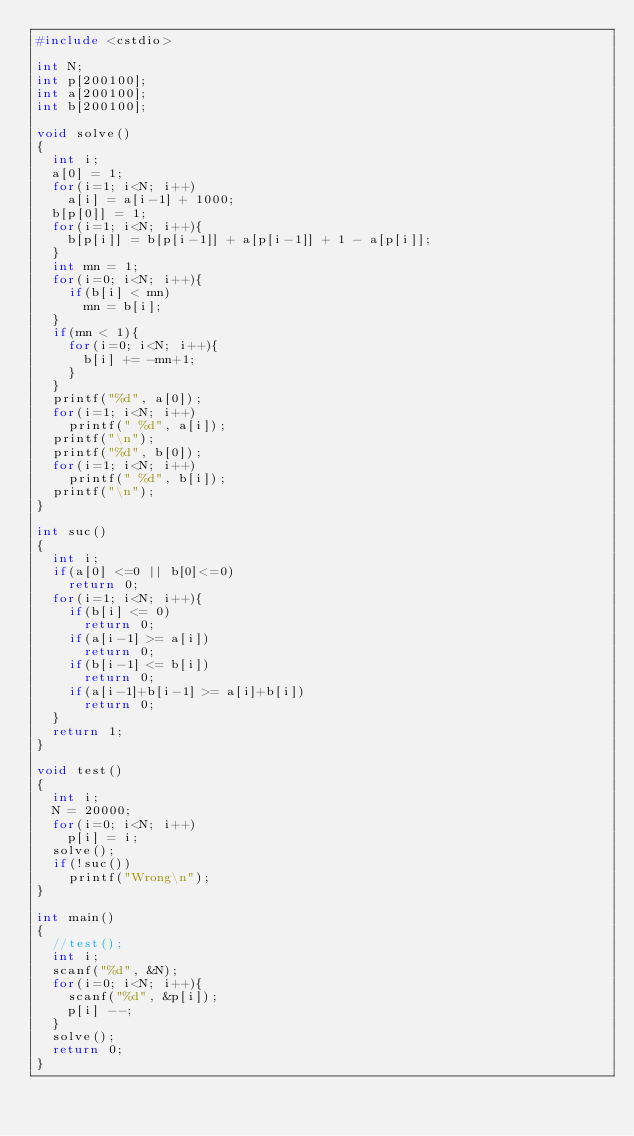<code> <loc_0><loc_0><loc_500><loc_500><_C++_>#include <cstdio>

int N;
int p[200100];
int a[200100];
int b[200100];

void solve()
{
	int i;
	a[0] = 1;
	for(i=1; i<N; i++)	
		a[i] = a[i-1] + 1000;
	b[p[0]] = 1;
	for(i=1; i<N; i++){
		b[p[i]] = b[p[i-1]] + a[p[i-1]] + 1 - a[p[i]];
	}
	int mn = 1;
	for(i=0; i<N; i++){
		if(b[i] < mn)
			mn = b[i];
	}
	if(mn < 1){
		for(i=0; i<N; i++){
			b[i] += -mn+1;
		}
	}
	printf("%d", a[0]);
	for(i=1; i<N; i++)
		printf(" %d", a[i]);
	printf("\n");
	printf("%d", b[0]);
	for(i=1; i<N; i++)
		printf(" %d", b[i]);
	printf("\n");
}

int suc()
{
	int i;
	if(a[0] <=0 || b[0]<=0)
		return 0;
	for(i=1; i<N; i++){
		if(b[i] <= 0)
			return 0;
		if(a[i-1] >= a[i])
			return 0;
		if(b[i-1] <= b[i])
			return 0;
		if(a[i-1]+b[i-1] >= a[i]+b[i])
			return 0;
	}
	return 1;
}

void test()
{
	int i;
	N = 20000;
	for(i=0; i<N; i++)
		p[i] = i;
	solve();
	if(!suc())
		printf("Wrong\n");
}

int main()
{
	//test();
	int i;
	scanf("%d", &N);
	for(i=0; i<N; i++){
		scanf("%d", &p[i]);
		p[i] --;
	}
	solve();
	return 0;
}</code> 